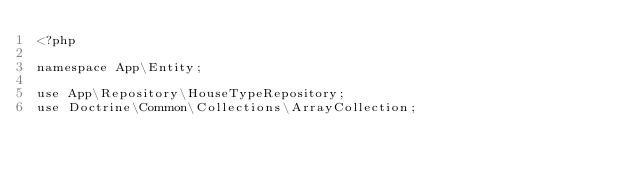<code> <loc_0><loc_0><loc_500><loc_500><_PHP_><?php

namespace App\Entity;

use App\Repository\HouseTypeRepository;
use Doctrine\Common\Collections\ArrayCollection;</code> 